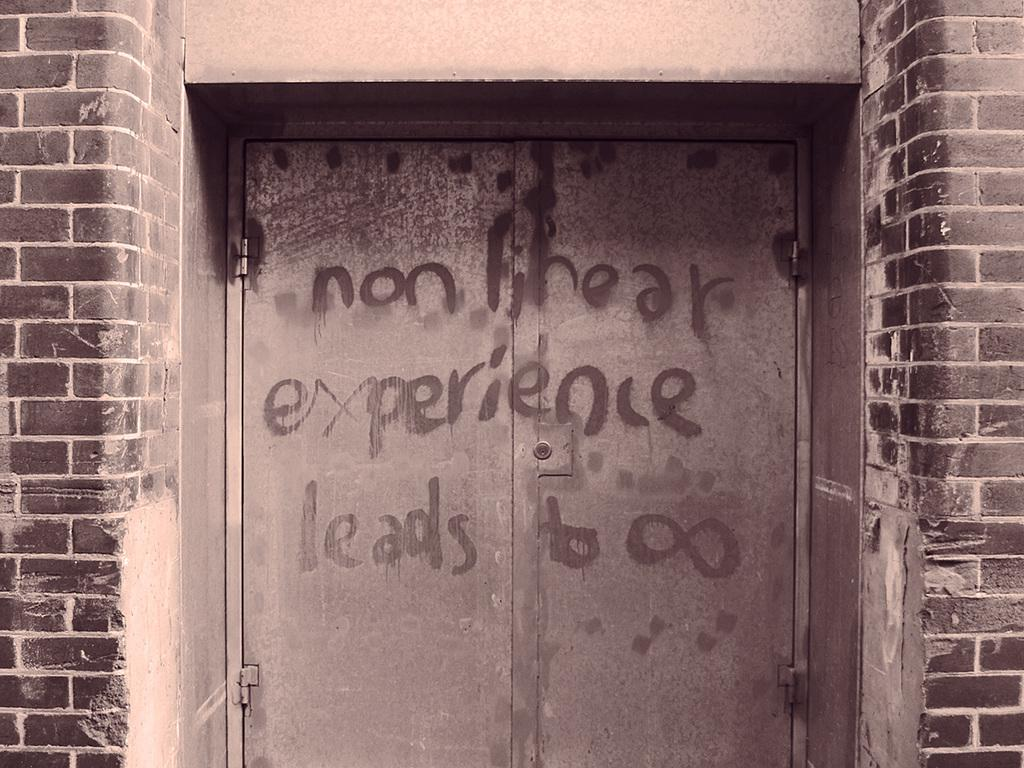What is one of the main features of the image? There is a door in the image. What can be seen on the door? The door has text on it. What else can be observed in the image? There are walls visible in the image. Where is the hole in the image? There is no hole present in the image. What type of spot can be seen on the door in the image? There are no spots visible on the door in the image; it only has text. 